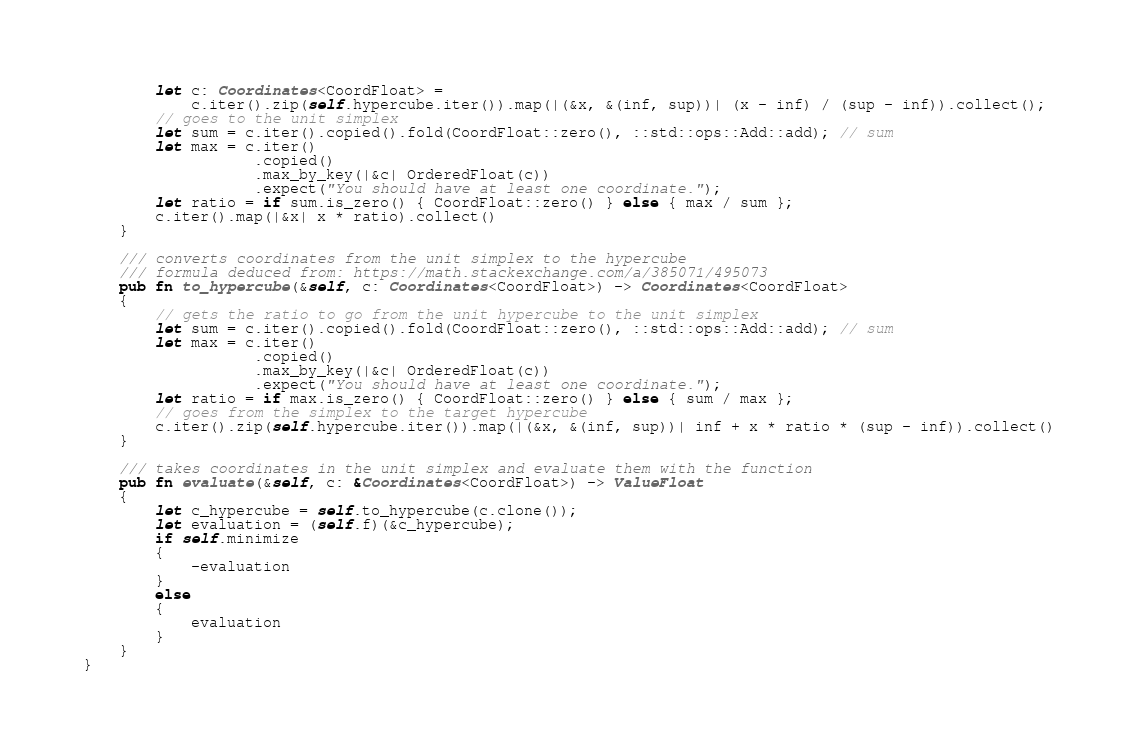<code> <loc_0><loc_0><loc_500><loc_500><_Rust_>        let c: Coordinates<CoordFloat> =
            c.iter().zip(self.hypercube.iter()).map(|(&x, &(inf, sup))| (x - inf) / (sup - inf)).collect();
        // goes to the unit simplex
        let sum = c.iter().copied().fold(CoordFloat::zero(), ::std::ops::Add::add); // sum
        let max = c.iter()
                   .copied()
                   .max_by_key(|&c| OrderedFloat(c))
                   .expect("You should have at least one coordinate.");
        let ratio = if sum.is_zero() { CoordFloat::zero() } else { max / sum };
        c.iter().map(|&x| x * ratio).collect()
    }

    /// converts coordinates from the unit simplex to the hypercube
    /// formula deduced from: https://math.stackexchange.com/a/385071/495073
    pub fn to_hypercube(&self, c: Coordinates<CoordFloat>) -> Coordinates<CoordFloat>
    {
        // gets the ratio to go from the unit hypercube to the unit simplex
        let sum = c.iter().copied().fold(CoordFloat::zero(), ::std::ops::Add::add); // sum
        let max = c.iter()
                   .copied()
                   .max_by_key(|&c| OrderedFloat(c))
                   .expect("You should have at least one coordinate.");
        let ratio = if max.is_zero() { CoordFloat::zero() } else { sum / max };
        // goes from the simplex to the target hypercube
        c.iter().zip(self.hypercube.iter()).map(|(&x, &(inf, sup))| inf + x * ratio * (sup - inf)).collect()
    }

    /// takes coordinates in the unit simplex and evaluate them with the function
    pub fn evaluate(&self, c: &Coordinates<CoordFloat>) -> ValueFloat
    {
        let c_hypercube = self.to_hypercube(c.clone());
        let evaluation = (self.f)(&c_hypercube);
        if self.minimize
        {
            -evaluation
        }
        else
        {
            evaluation
        }
    }
}
</code> 